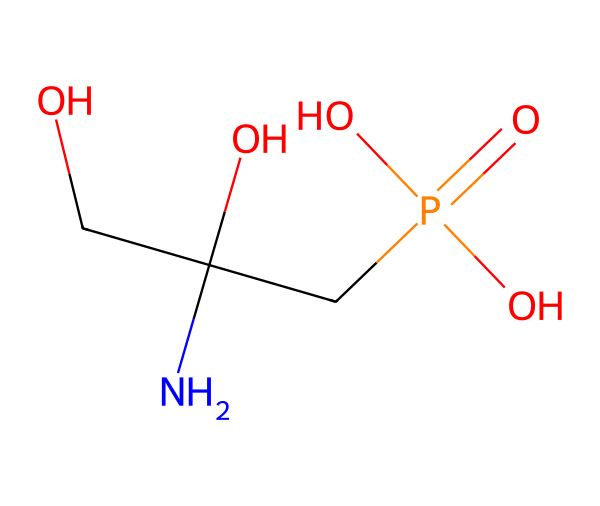What is the molecular formula of glyphosate? To find the molecular formula, we can count the atoms present in the SMILES representation. The structure shows carbon (C), hydrogen (H), nitrogen (N), phosphorus (P), and oxygen (O). By identifying the number of each atom type, we get C3, H8, N1, P1, O4. Therefore, the molecular formula is C3H8N1P1O4.
Answer: C3H8N1P1O4 How many carbon atoms are in glyphosate? By examining the SMILES representation, we can identify that there are three carbon (C) atoms present in the structure.
Answer: 3 Does glyphosate contain phosphorus? In the SMILES structure, there is one phosphorus (P) atom indicated as the central atom in the phosphate group, confirming its presence in glyphosate.
Answer: yes What is the primary functional group in glyphosate? Analyzing the chemical structure, glyphosate contains a carboxylic acid group (-COOH) and a phosphonate group, but the most prominent functional group relevant to herbicides is the phosphonate, indicated by the presence of the phosphorus atom.
Answer: phosphonate Is glyphosate a systemic herbicide? Glyphosate is designed to be absorbed by foliage and then translocated throughout the plant, affecting all parts of it, which classifies it as a systemic herbicide.
Answer: yes How many oxygen atoms are present in glyphosate? In the given SMILES structure, there are four oxygen (O) atoms present that can be identified in the phosphate and carboxylic acid functional groups.
Answer: 4 